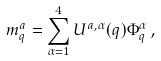<formula> <loc_0><loc_0><loc_500><loc_500>m _ { q } ^ { a } = \sum _ { \alpha = 1 } ^ { 4 } U ^ { a , \alpha } ( { q } ) \Phi _ { q } ^ { \alpha } \, ,</formula> 